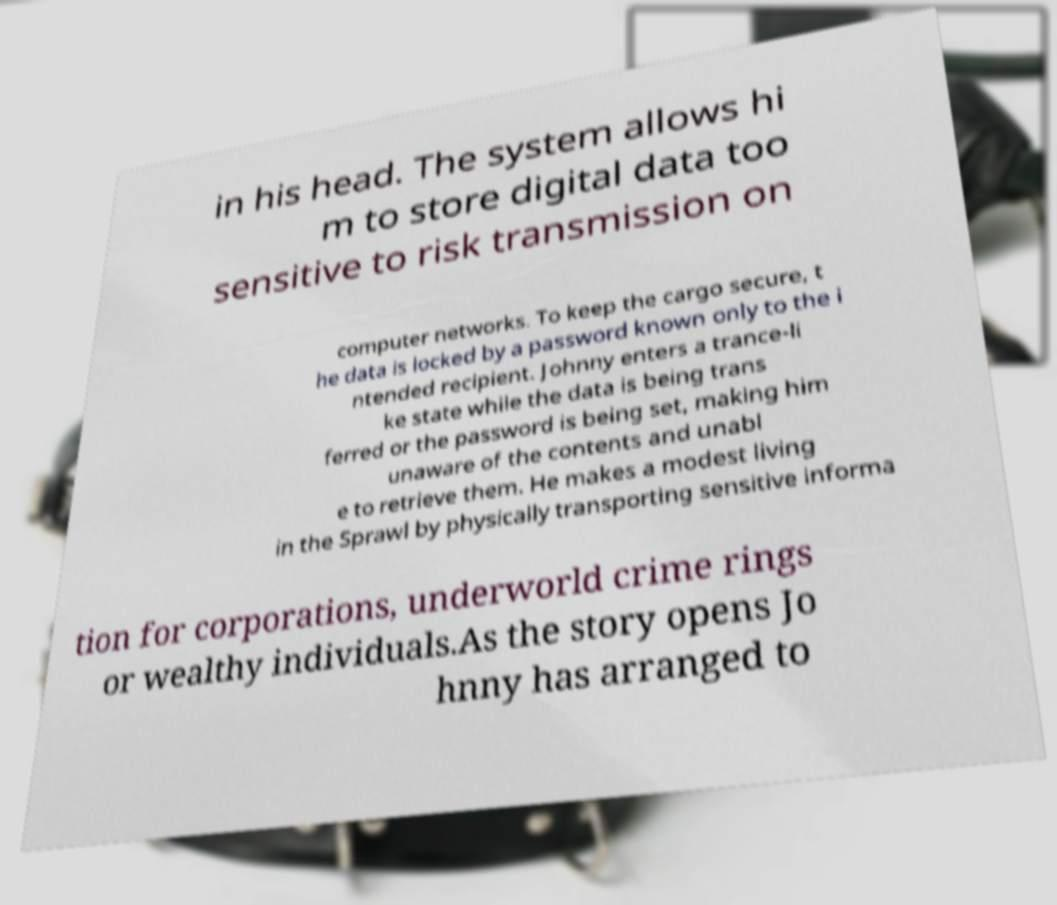Could you assist in decoding the text presented in this image and type it out clearly? in his head. The system allows hi m to store digital data too sensitive to risk transmission on computer networks. To keep the cargo secure, t he data is locked by a password known only to the i ntended recipient. Johnny enters a trance-li ke state while the data is being trans ferred or the password is being set, making him unaware of the contents and unabl e to retrieve them. He makes a modest living in the Sprawl by physically transporting sensitive informa tion for corporations, underworld crime rings or wealthy individuals.As the story opens Jo hnny has arranged to 